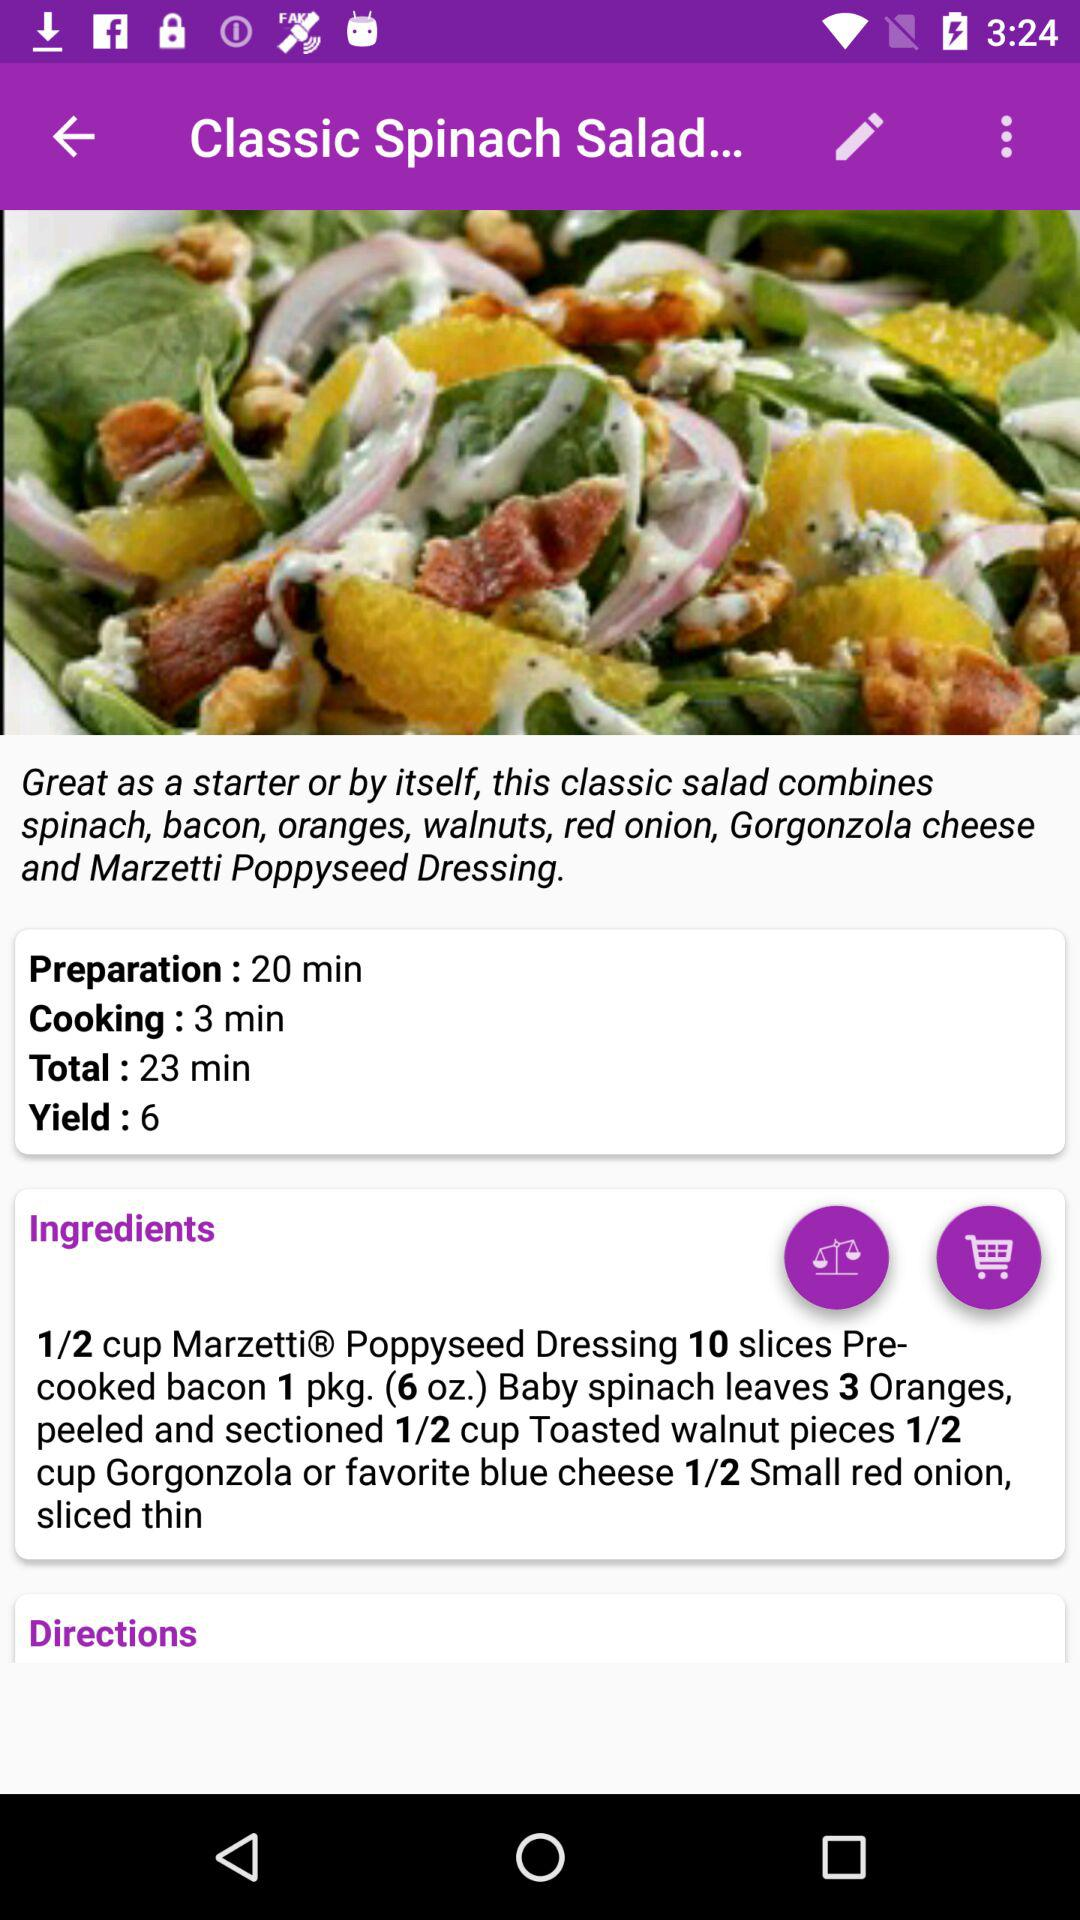What is the required quantity of walnuts in the dish? The required quantity of walnuts in the dish is 1/2 cup. 